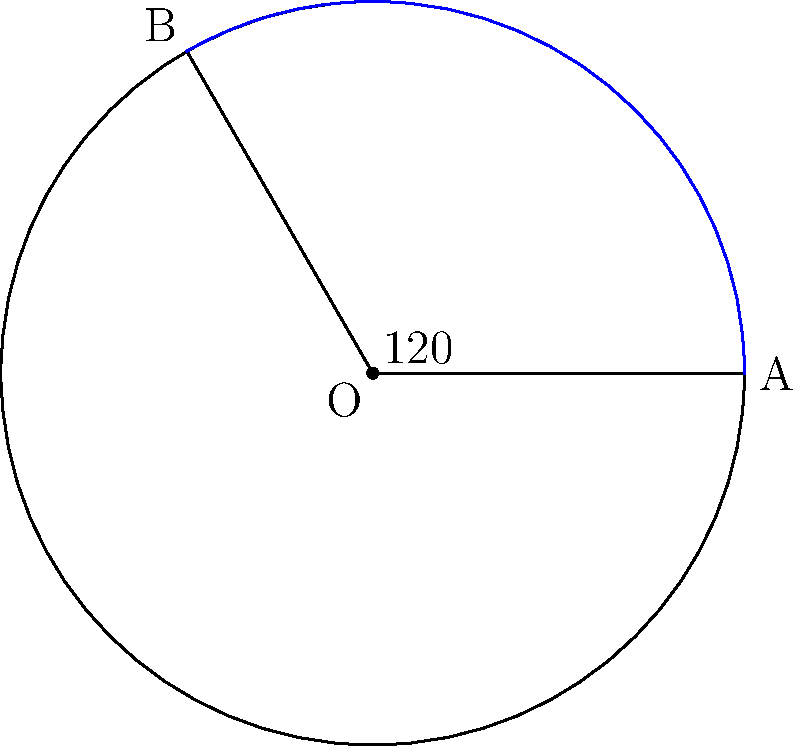In your practice, you often use visual aids to help clients understand complex emotional concepts. Consider a circular diagram representing a person's emotional spectrum, where the entire circle symbolizes their full range of emotions. If a specific emotion sector spans a central angle of 120°, and the radius of the circle is 10 cm, what is the area of this emotional sector? Round your answer to two decimal places. To solve this problem, we'll use the formula for the area of a circular sector:

$$ A = \frac{\theta}{360°} \pi r^2 $$

Where:
- $A$ is the area of the sector
- $\theta$ is the central angle in degrees
- $r$ is the radius of the circle

Step 1: Identify the given information
- Central angle $\theta = 120°$
- Radius $r = 10$ cm

Step 2: Substitute the values into the formula
$$ A = \frac{120°}{360°} \pi (10 \text{ cm})^2 $$

Step 3: Simplify
$$ A = \frac{1}{3} \pi (100 \text{ cm}^2) $$

Step 4: Calculate (using $\pi \approx 3.14159$)
$$ A \approx \frac{1}{3} (3.14159) (100 \text{ cm}^2) \approx 104.72 \text{ cm}^2 $$

Step 5: Round to two decimal places
$$ A \approx 104.72 \text{ cm}^2 $$
Answer: 104.72 cm² 